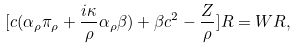<formula> <loc_0><loc_0><loc_500><loc_500>[ c ( \alpha _ { \rho } \pi _ { \rho } + \frac { i \kappa } { \rho } \alpha _ { \rho } \beta ) + \beta c ^ { 2 } - \frac { Z } { \rho } ] R = W R ,</formula> 